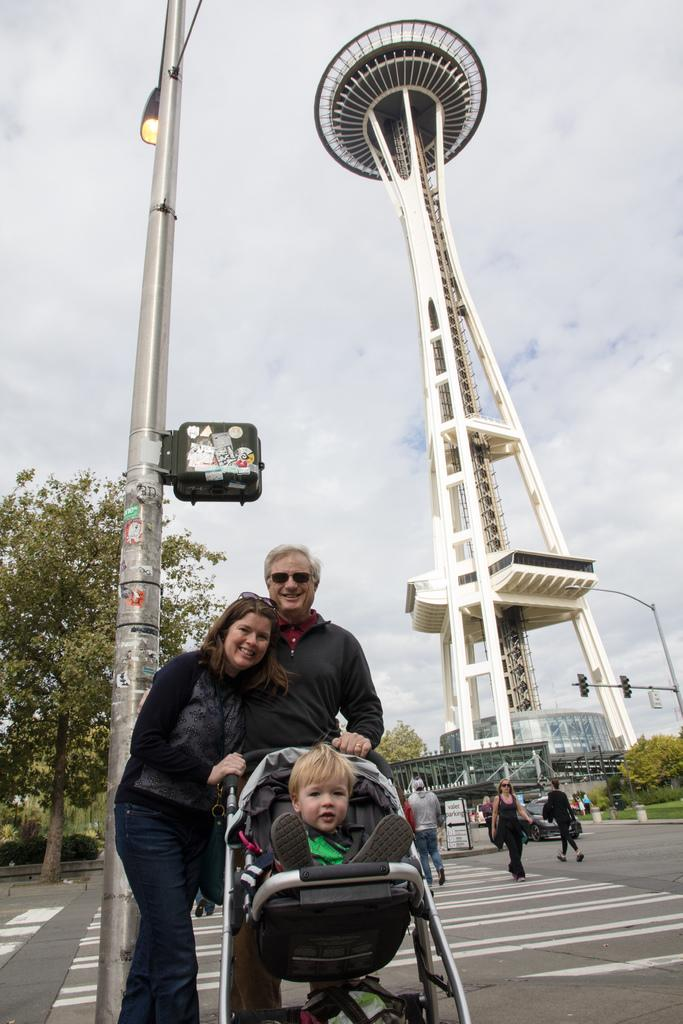What are the people in the image doing? The people in the image are walking on the road. What structure can be seen in the image? There is a tower visible in the image. What type of vegetation is present in the image? There are trees in the image. Reasoning: Let'ing: Let's think step by step in order to produce the conversation. We start by identifying the main subjects in the image, which are the people walking on the road. Then, we expand the conversation to include other elements that are also visible, such as the tower and trees. Each question is designed to elicit a specific detail about the image that is known from the provided facts. Absurd Question/Answer: How many stamps are on the van in the image? There is no van or stamp present in the image. What type of women can be seen in the image? There is no reference to women in the image; it only shows people walking on the road, a tower, and trees. What type of women can be seen in the image? There is no reference to women in the image; it only shows people walking on the road, a tower, and trees. --- Facts: 1. There is a car in the image. 2. The car is red. 3. The car has four wheels. 4. There is a road in the image. 5. The road is paved. Absurd Topics: parrot, sand, mountain Conversation: What is the color of the car in the image? The car is red. How many wheels does the car have? The car has four wheels. What type of surface is the road made of in the image? The road is paved. Reasoning: Let's think step by step in order to produce the conversation. We start by identifying the main subject in the image, which is the car. Then, we describe specific features of the car, such as its color and the number of wheels. Finally, we observe the road's surface, noting that it is paved. Absurd Question/Answer: Can you see a parrot sitting on the mountain in the image? There is no mountain or parrot present in the image. 